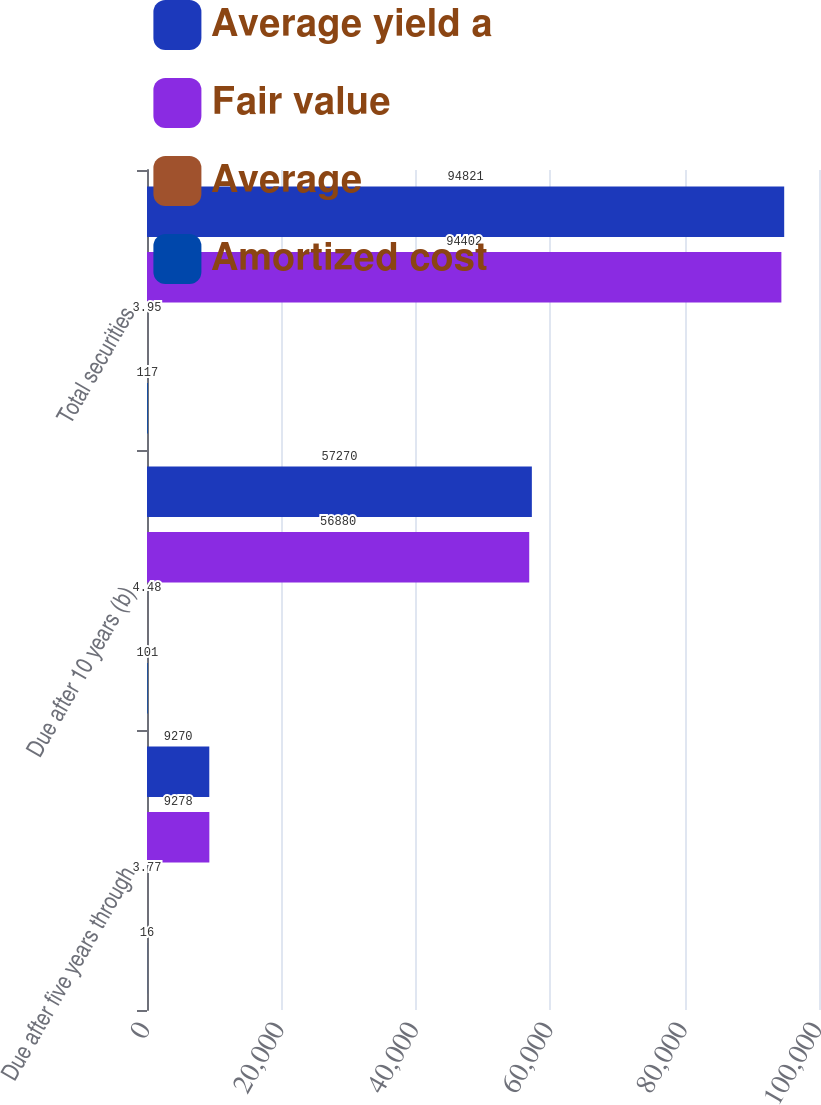Convert chart to OTSL. <chart><loc_0><loc_0><loc_500><loc_500><stacked_bar_chart><ecel><fcel>Due after five years through<fcel>Due after 10 years (b)<fcel>Total securities<nl><fcel>Average yield a<fcel>9270<fcel>57270<fcel>94821<nl><fcel>Fair value<fcel>9278<fcel>56880<fcel>94402<nl><fcel>Average<fcel>3.77<fcel>4.48<fcel>3.95<nl><fcel>Amortized cost<fcel>16<fcel>101<fcel>117<nl></chart> 